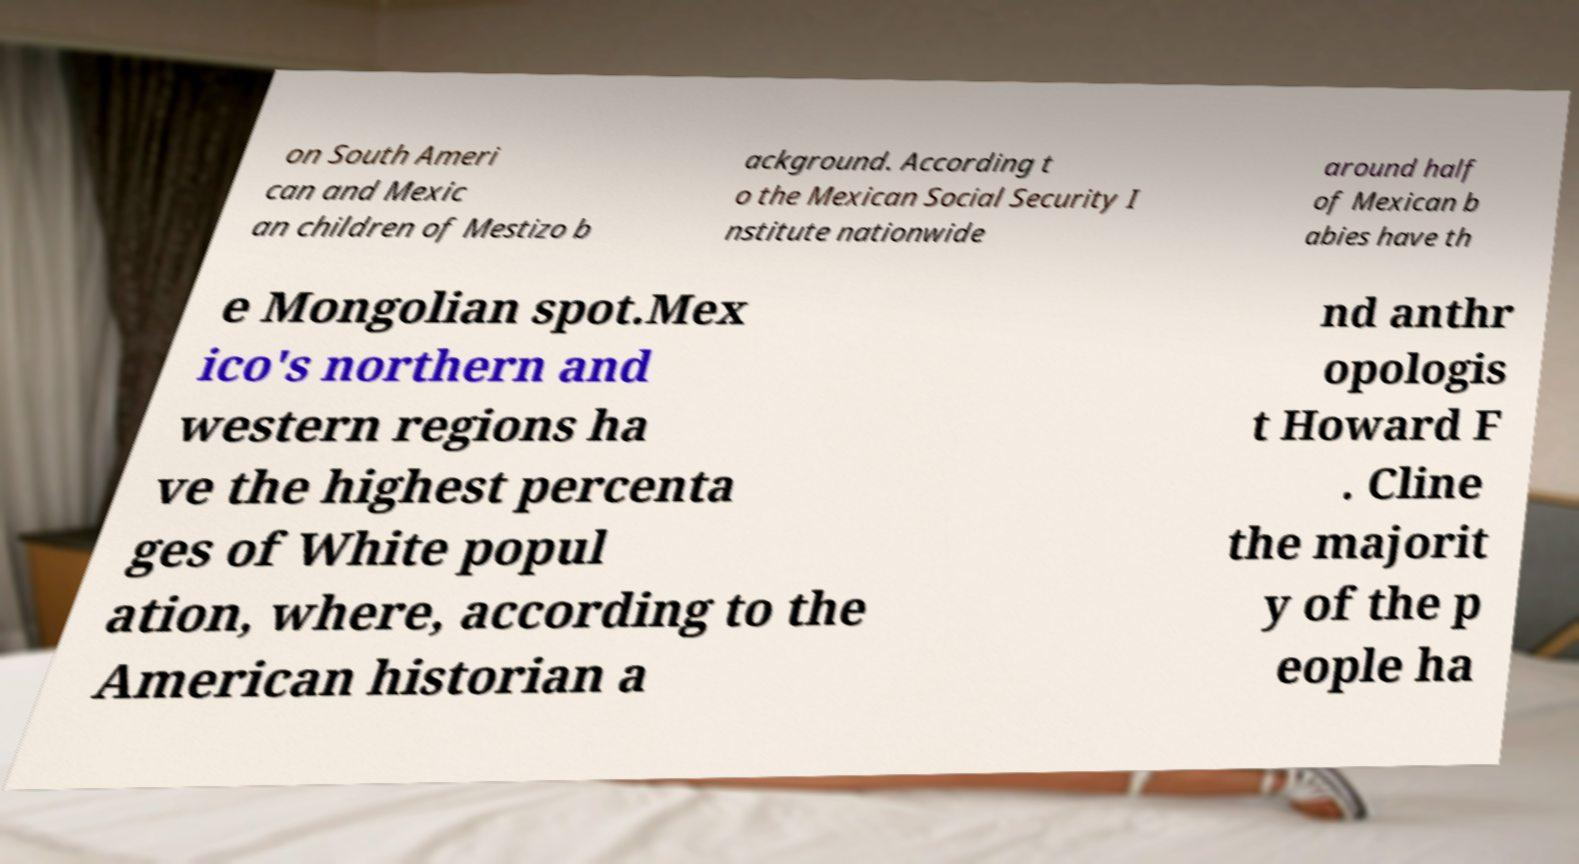Could you extract and type out the text from this image? on South Ameri can and Mexic an children of Mestizo b ackground. According t o the Mexican Social Security I nstitute nationwide around half of Mexican b abies have th e Mongolian spot.Mex ico's northern and western regions ha ve the highest percenta ges of White popul ation, where, according to the American historian a nd anthr opologis t Howard F . Cline the majorit y of the p eople ha 